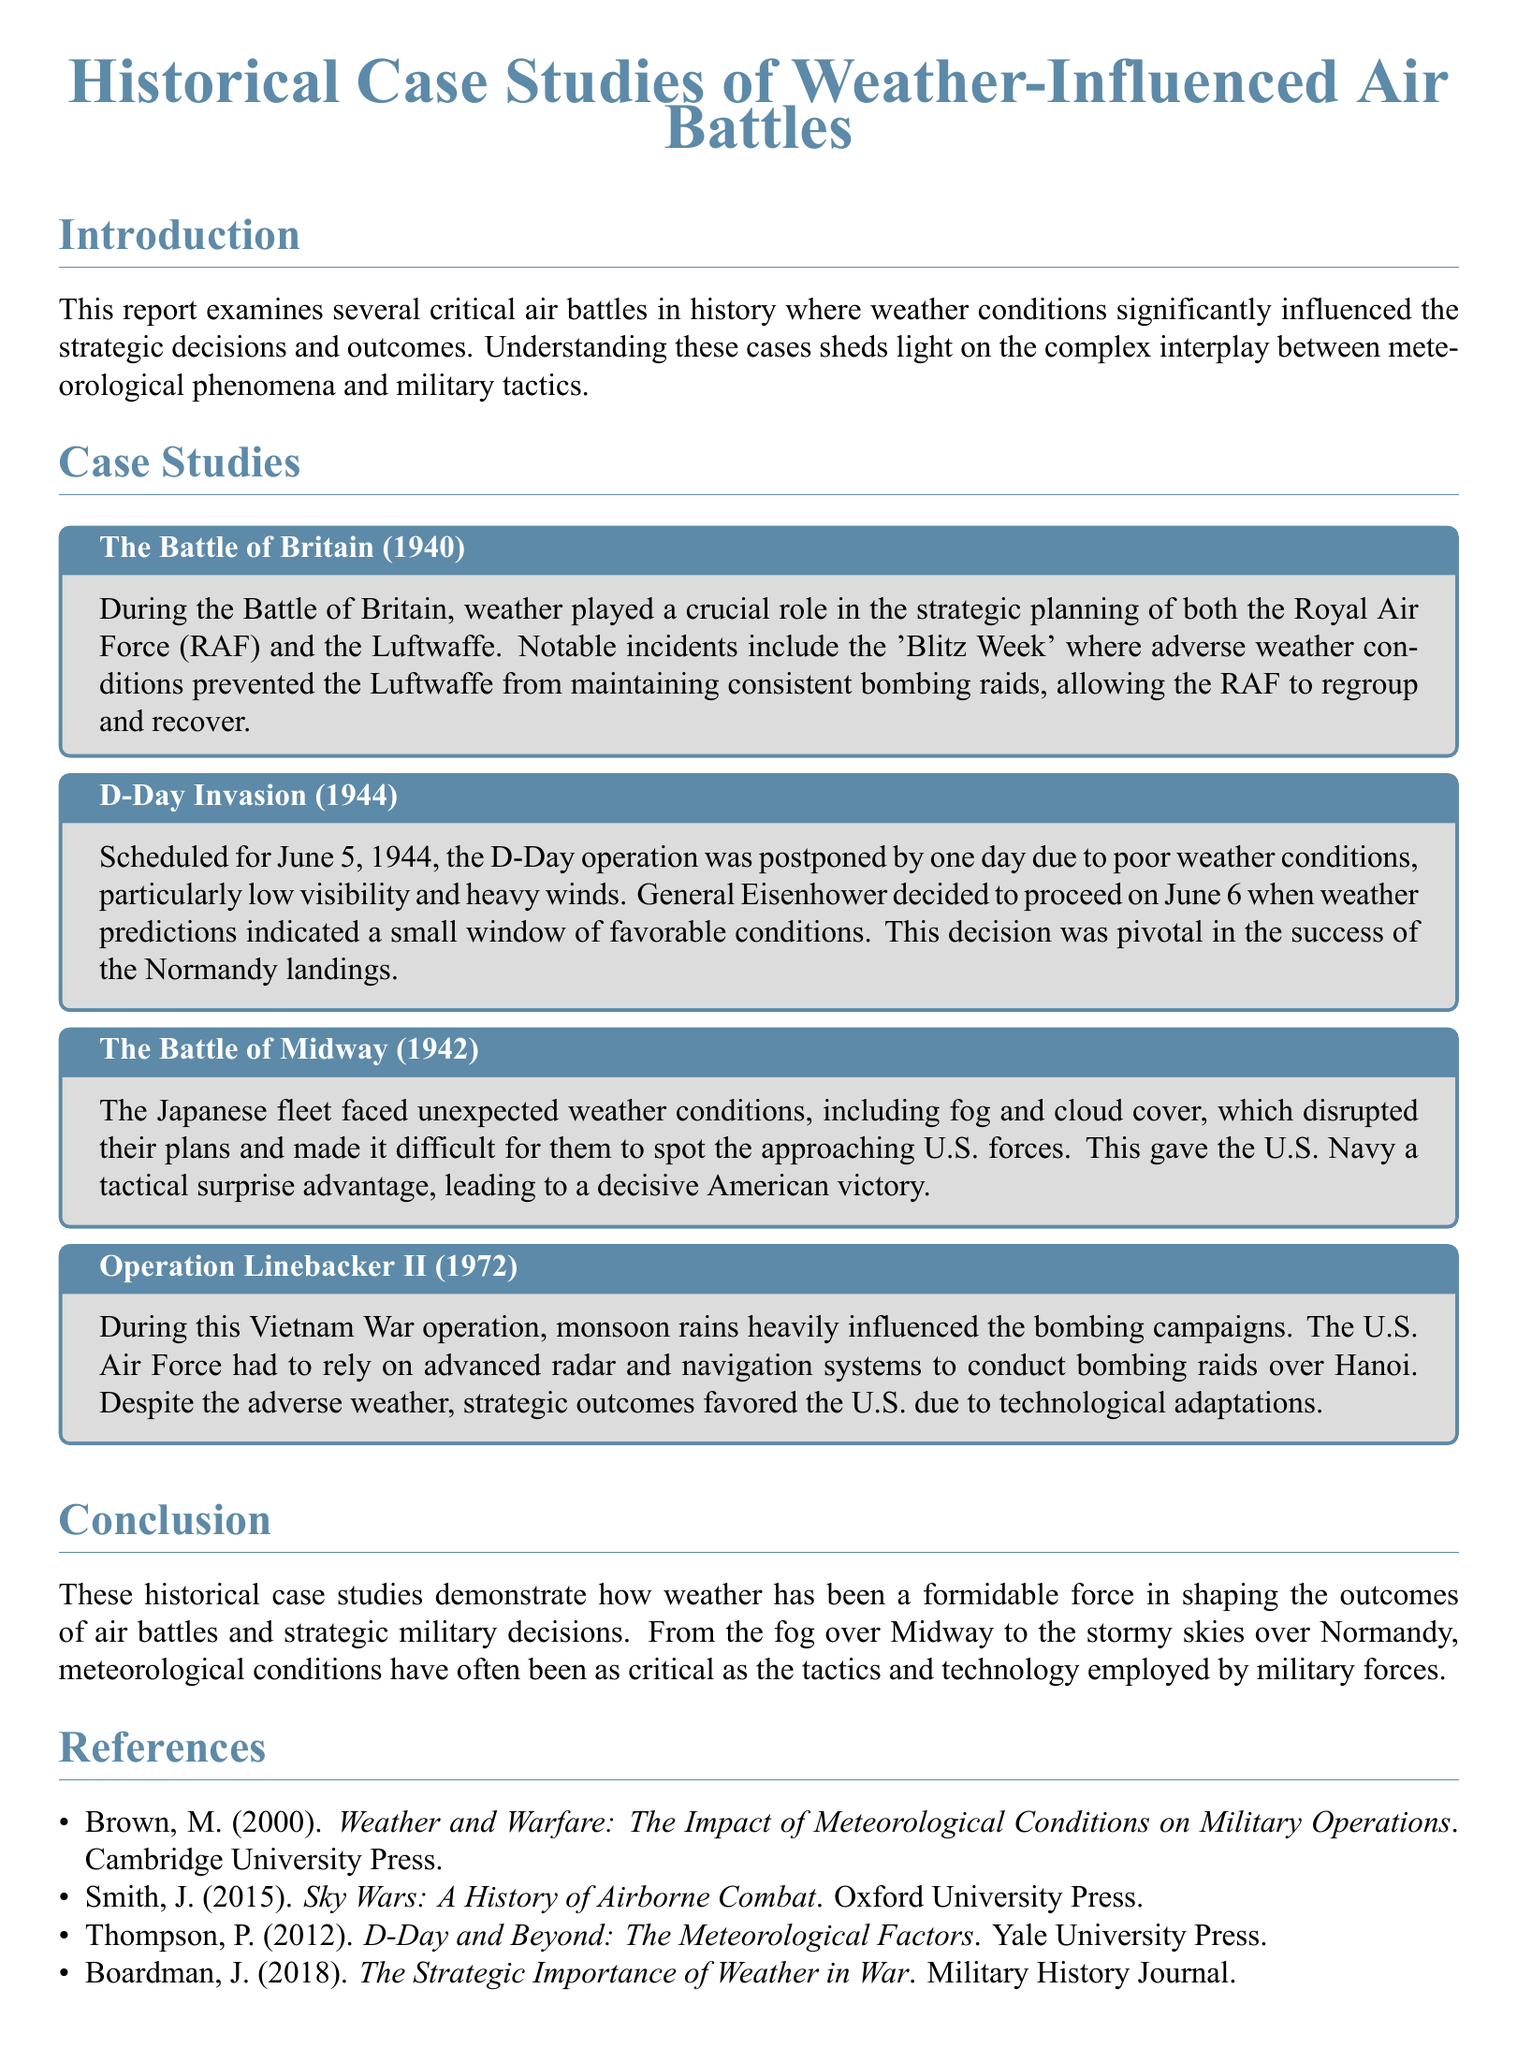What was the major strategic decision during the D-Day Invasion? The weather conditions particularly influenced the decision to postpone the D-Day operation originally scheduled for June 5, 1944.
Answer: Postponed one day What year did the Battle of Midway take place? The Battle of Midway is mentioned as occurring in 1942 within the document.
Answer: 1942 Which military forces were involved in the Battle of Britain? The document specifies the Royal Air Force (RAF) and the Luftwaffe as the main forces in the Battle of Britain.
Answer: RAF and Luftwaffe What weather phenomenon impacted Operation Linebacker II? The document states that monsoon rains were a significant weather influence during this operation.
Answer: Monsoon rains How did weather affect the Japanese fleet during the Battle of Midway? The unexpected weather conditions included fog and cloud cover, which disrupted their plans and gave the U.S. Navy a tactical surprise advantage.
Answer: Fog and cloud cover What was the weather condition that led to weather-related strategic decisions in the Battle of Britain? The document highlights adverse weather conditions during 'Blitz Week' that prevented bombing raids by the Luftwaffe.
Answer: Adverse weather conditions Which publication discusses the meteorological factors of D-Day? The references section attributes the discussion of meteorological factors of D-Day to Thompson's work.
Answer: Thompson, P. (2012) What technological adaptations did the U.S. Air Force rely on during Operation Linebacker II? Advanced radar and navigation systems, as mentioned in the document, were crucial for conducting bombing raids.
Answer: Advanced radar and navigation systems 